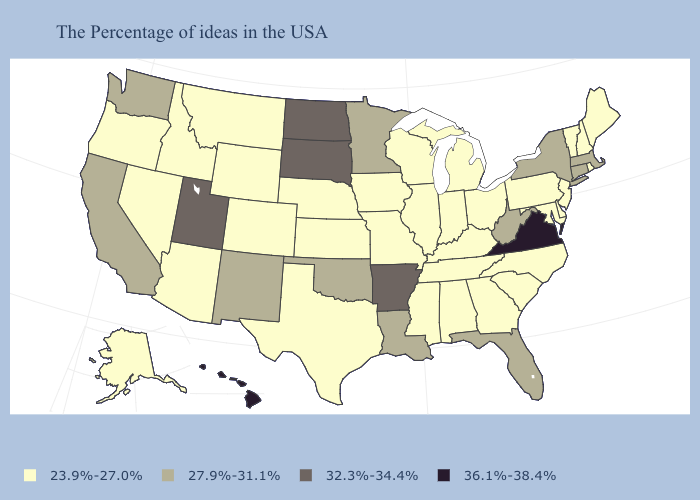Does Texas have the lowest value in the South?
Be succinct. Yes. Name the states that have a value in the range 36.1%-38.4%?
Write a very short answer. Virginia, Hawaii. What is the value of Illinois?
Quick response, please. 23.9%-27.0%. What is the value of Iowa?
Concise answer only. 23.9%-27.0%. Name the states that have a value in the range 27.9%-31.1%?
Short answer required. Massachusetts, Connecticut, New York, West Virginia, Florida, Louisiana, Minnesota, Oklahoma, New Mexico, California, Washington. What is the value of Louisiana?
Give a very brief answer. 27.9%-31.1%. Name the states that have a value in the range 36.1%-38.4%?
Short answer required. Virginia, Hawaii. What is the value of Kentucky?
Be succinct. 23.9%-27.0%. Does the first symbol in the legend represent the smallest category?
Quick response, please. Yes. What is the highest value in the MidWest ?
Give a very brief answer. 32.3%-34.4%. What is the value of South Carolina?
Write a very short answer. 23.9%-27.0%. Name the states that have a value in the range 23.9%-27.0%?
Answer briefly. Maine, Rhode Island, New Hampshire, Vermont, New Jersey, Delaware, Maryland, Pennsylvania, North Carolina, South Carolina, Ohio, Georgia, Michigan, Kentucky, Indiana, Alabama, Tennessee, Wisconsin, Illinois, Mississippi, Missouri, Iowa, Kansas, Nebraska, Texas, Wyoming, Colorado, Montana, Arizona, Idaho, Nevada, Oregon, Alaska. What is the highest value in the South ?
Short answer required. 36.1%-38.4%. Does New York have the lowest value in the Northeast?
Be succinct. No. Does Alabama have a higher value than Ohio?
Concise answer only. No. 